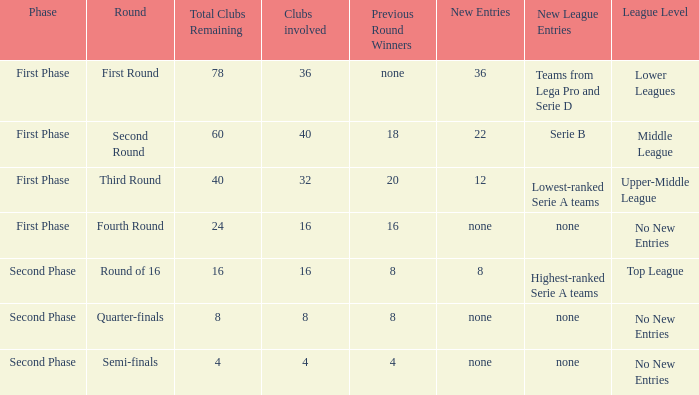Clubs involved is 8, what number would you find from winners from previous round? 8.0. 